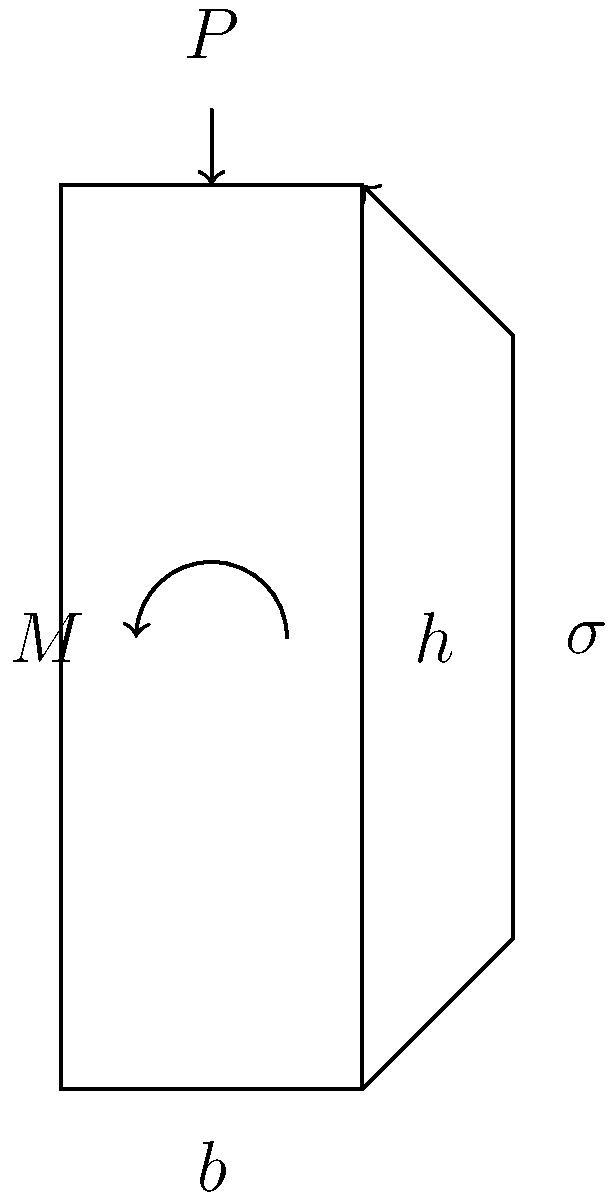As a civil engineer working on a project in Brunei, you're analyzing a rectangular concrete column with width $b$ and height $h$. The column is subjected to an axial load $P$ and a bending moment $M$. Using the stress distribution shown, derive an expression for the maximum compressive stress $\sigma_{max}$ in terms of $P$, $M$, $b$, and $h$. Assume linear elastic behavior. Let's approach this step-by-step:

1) The stress distribution in the column is a combination of uniform stress due to axial load and linear stress due to bending moment.

2) Stress due to axial load:
   $$\sigma_P = \frac{P}{A} = \frac{P}{bh}$$

3) Maximum stress due to bending moment:
   $$\sigma_M = \frac{Mc}{I}$$
   where $c = h/2$ (distance from neutral axis to extreme fiber)
   and $I = \frac{bh^3}{12}$ (moment of inertia for rectangular section)

4) Substituting these values:
   $$\sigma_M = \frac{M(h/2)}{\frac{bh^3}{12}} = \frac{6M}{bh^2}$$

5) The maximum compressive stress occurs where these stresses add:
   $$\sigma_{max} = \sigma_P + \sigma_M = \frac{P}{bh} + \frac{6M}{bh^2}$$

6) Simplifying:
   $$\sigma_{max} = \frac{P}{bh} + \frac{6M}{bh^2}$$

This expression gives the maximum compressive stress in the column under the combined axial load and bending moment.
Answer: $$\sigma_{max} = \frac{P}{bh} + \frac{6M}{bh^2}$$ 